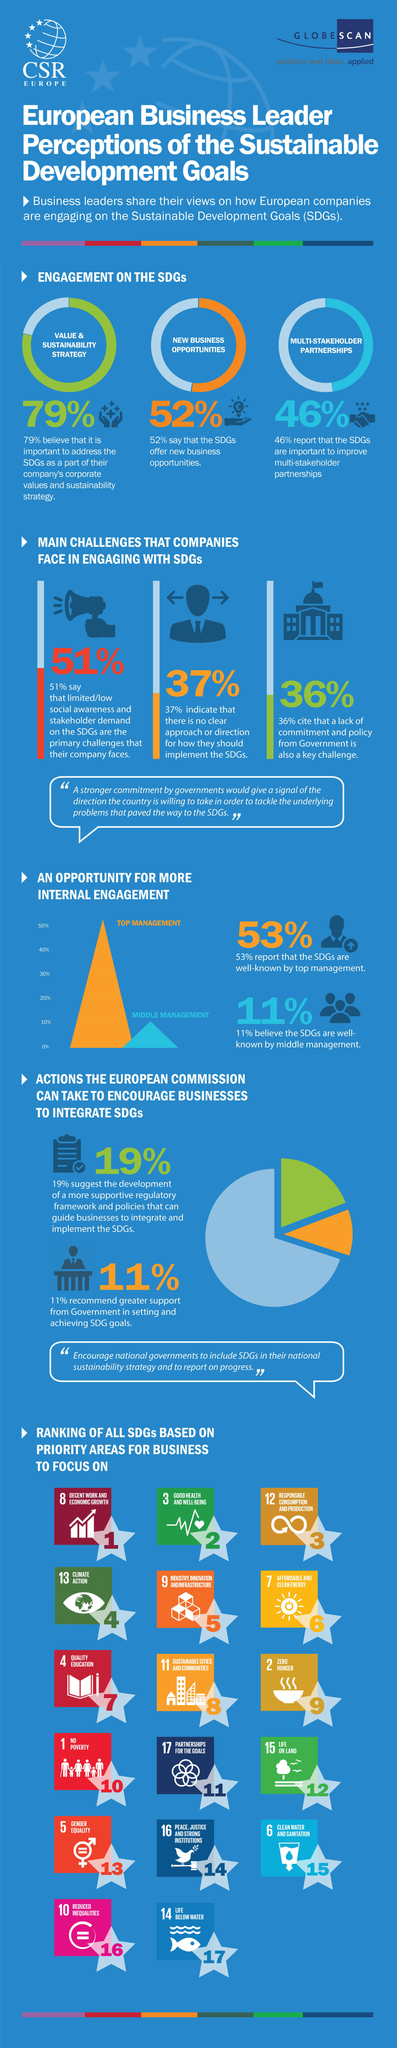Highlight a few significant elements in this photo. A substantial proportion of individuals, or 37%, believe that the Sustainable Development Goals lack clarity on the specific goals that have been committed to. Out of the new opportunities presented, 79%, 46%, and 52% were identified as viable options. 